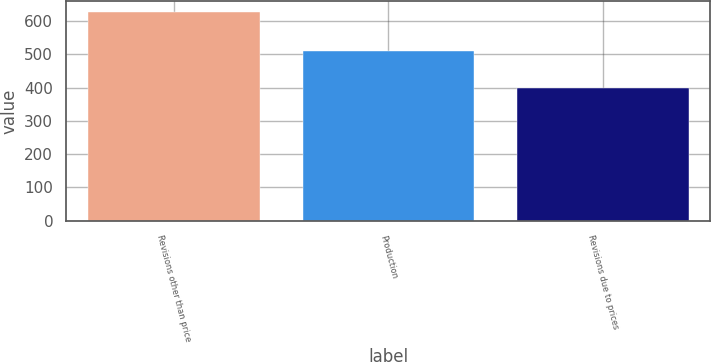Convert chart to OTSL. <chart><loc_0><loc_0><loc_500><loc_500><bar_chart><fcel>Revisions other than price<fcel>Production<fcel>Revisions due to prices<nl><fcel>628<fcel>510<fcel>398<nl></chart> 